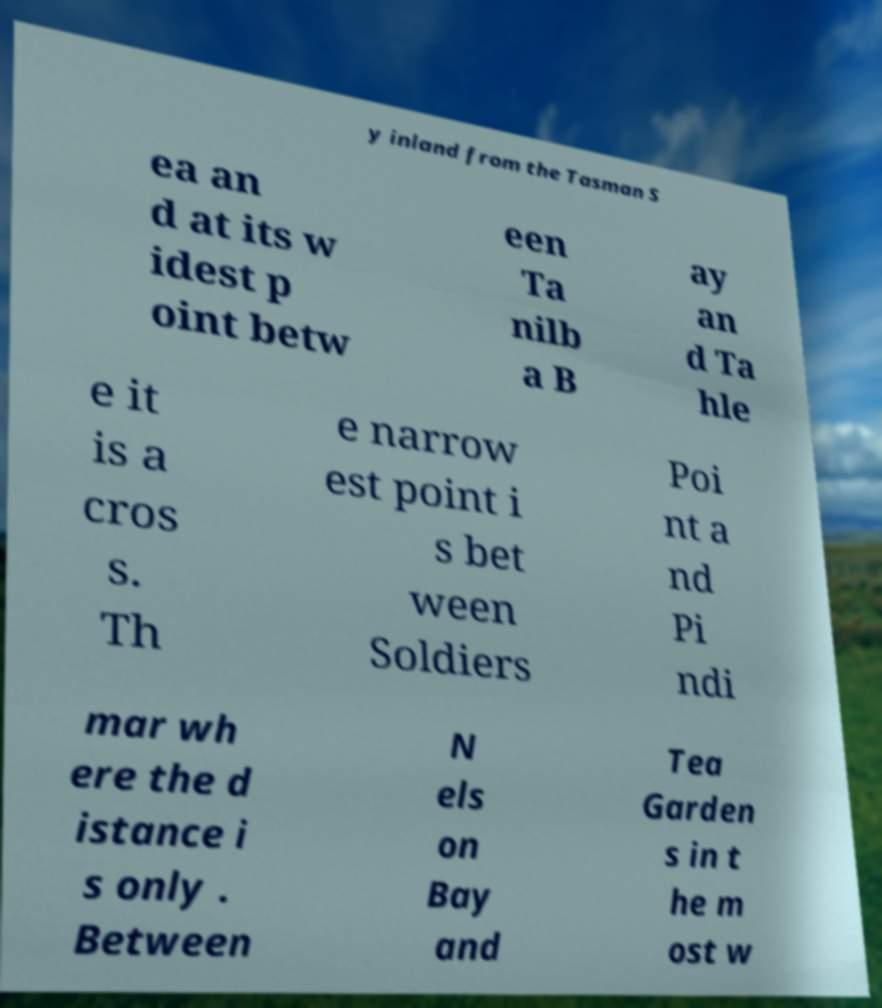Can you read and provide the text displayed in the image?This photo seems to have some interesting text. Can you extract and type it out for me? y inland from the Tasman S ea an d at its w idest p oint betw een Ta nilb a B ay an d Ta hle e it is a cros s. Th e narrow est point i s bet ween Soldiers Poi nt a nd Pi ndi mar wh ere the d istance i s only . Between N els on Bay and Tea Garden s in t he m ost w 